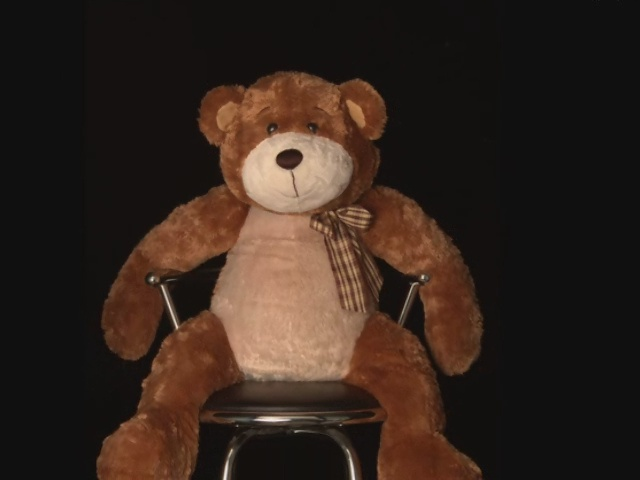Describe the objects in this image and their specific colors. I can see teddy bear in black, maroon, and tan tones and chair in black, maroon, and gray tones in this image. 